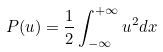<formula> <loc_0><loc_0><loc_500><loc_500>P ( u ) = \frac { 1 } { 2 } \int _ { - \infty } ^ { + \infty } u ^ { 2 } d x</formula> 